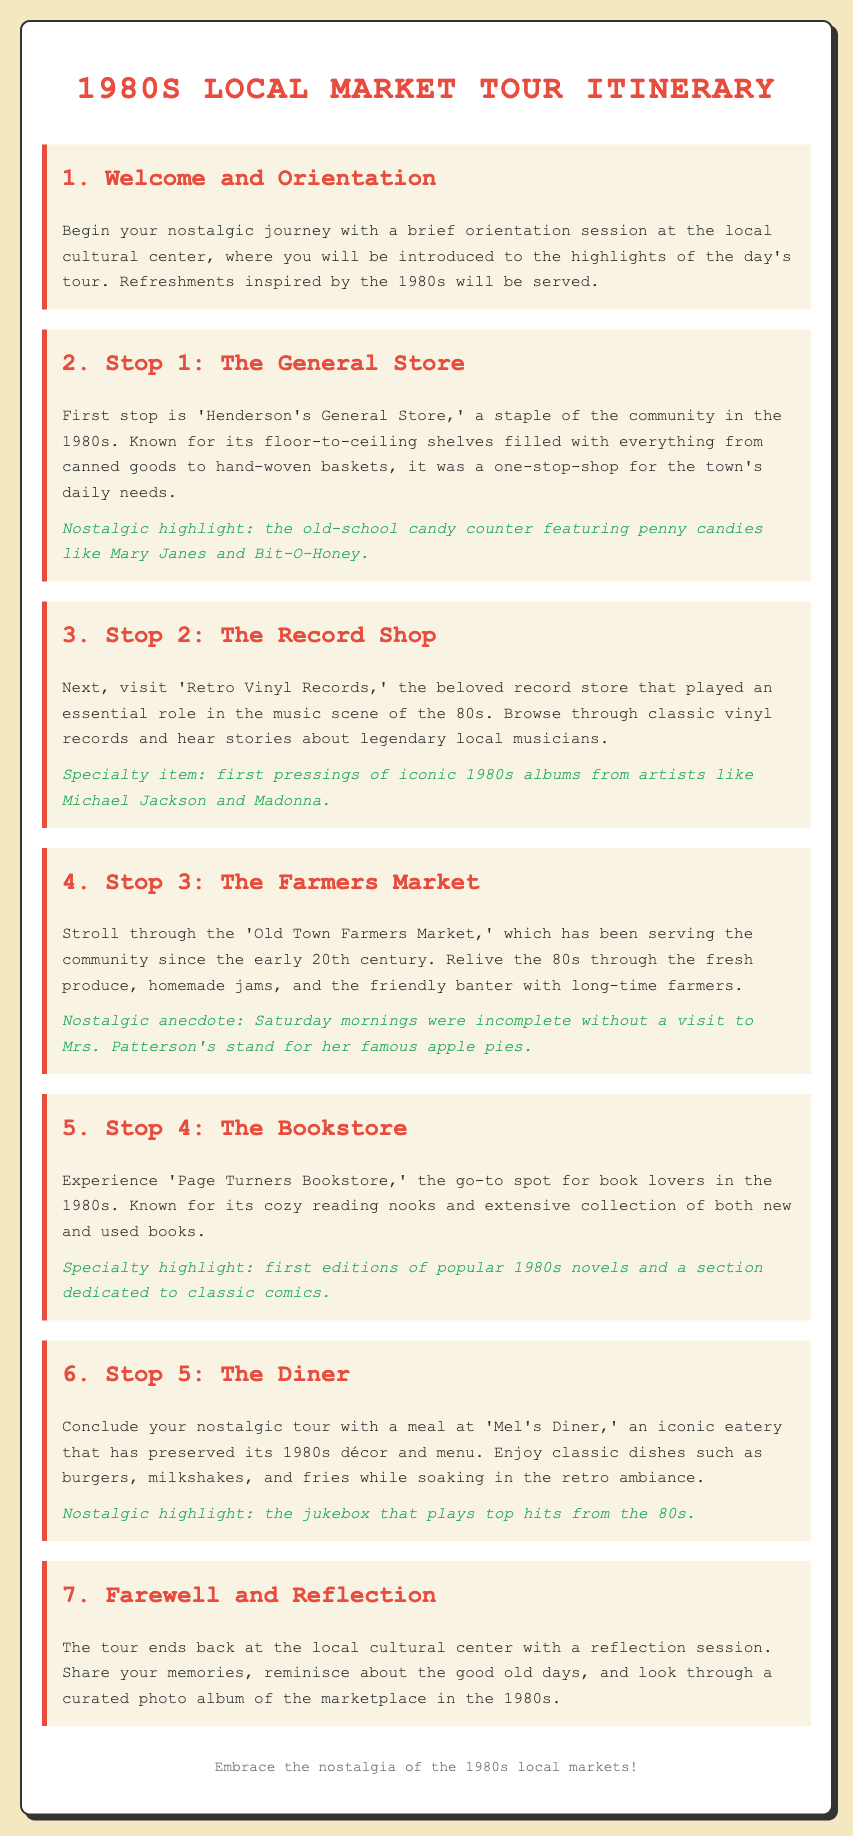What is the first stop on the tour? The first stop mentioned in the itinerary is 'Henderson's General Store.'
Answer: Henderson's General Store What notable item could you find at the candy counter? The candy counter is highlighted for featuring penny candies like Mary Janes and Bit-O-Honey.
Answer: Penny candies What is the specialty item at 'Retro Vinyl Records'? The specialty item listed is first pressings of iconic 1980s albums from artists like Michael Jackson and Madonna.
Answer: First pressings of iconic 1980s albums Which stand was essential on Saturday mornings? The stand that was noted as essential on Saturday mornings was Mrs. Patterson's for her famous apple pies.
Answer: Mrs. Patterson's Where does the tour conclude? The tour conclusion takes place back at the local cultural center.
Answer: Local cultural center What type of food is served at 'Mel's Diner'? The diner serves classic dishes such as burgers, milkshakes, and fries.
Answer: Burgers, milkshakes, and fries What nostalgic feature is found at 'Mel's Diner'? The nostalgic feature mentioned is the jukebox that plays top hits from the 80s.
Answer: Jukebox What can participants do during the reflection session? Participants can share their memories and reminisce about the good old days.
Answer: Share memories 